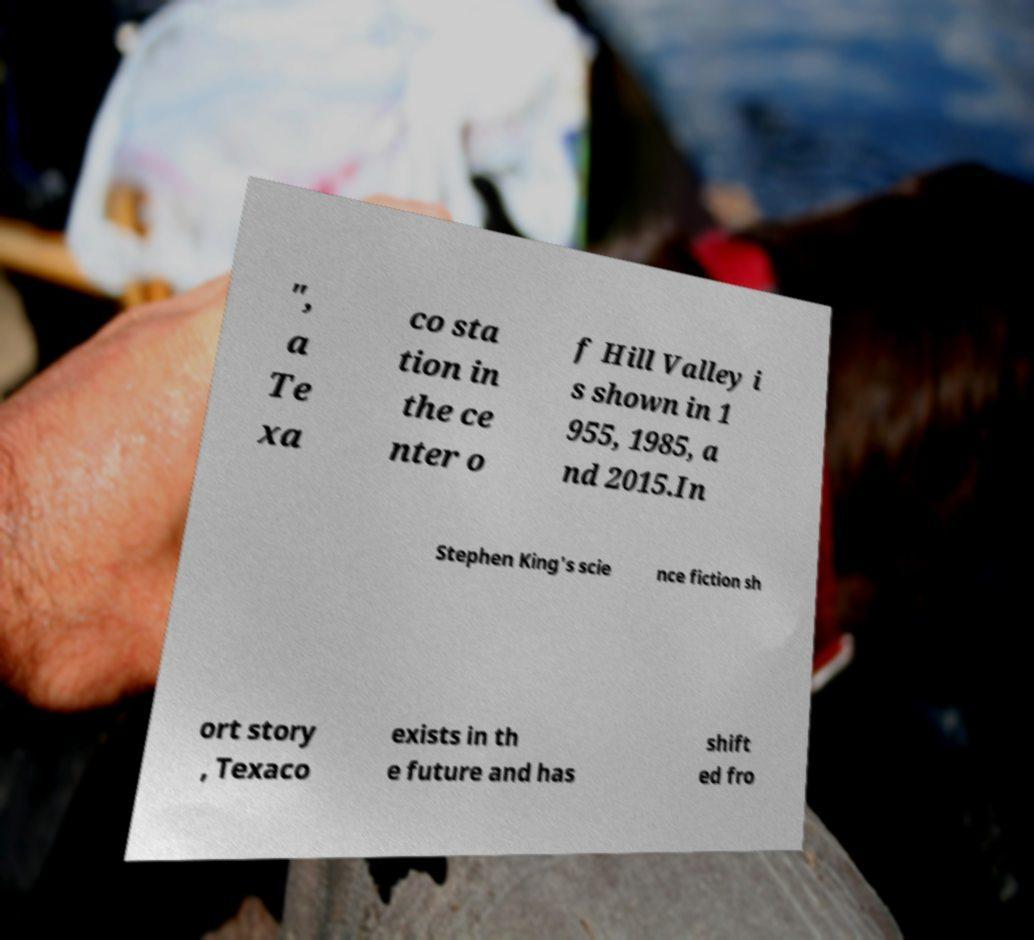Could you extract and type out the text from this image? ", a Te xa co sta tion in the ce nter o f Hill Valley i s shown in 1 955, 1985, a nd 2015.In Stephen King's scie nce fiction sh ort story , Texaco exists in th e future and has shift ed fro 